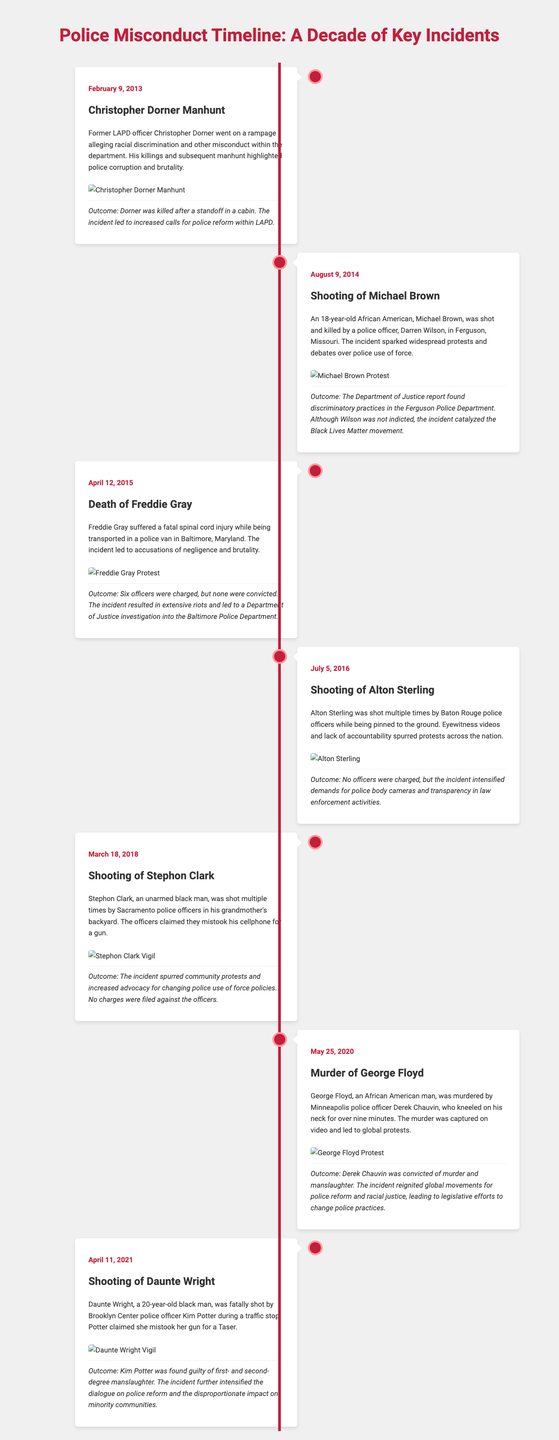What incident occurred on February 9, 2013? The incident that occurred on this date was the Christopher Dorner Manhunt, which involved allegations of racial discrimination and misconduct within the LAPD.
Answer: Christopher Dorner Manhunt Who was shot on August 9, 2014? On this date, Michael Brown, an 18-year-old African American, was shot and killed by a police officer in Ferguson, Missouri.
Answer: Michael Brown How many officers were charged in the Freddie Gray case? Six officers were charged in the incident involving Freddie Gray, but no convictions followed.
Answer: Six What sparked widespread protests after the shooting of Alton Sterling? Eyewitness videos and lack of accountability for the officers involved spurred protests across the nation.
Answer: Eyewitness videos What was the outcome of the George Floyd murder? Derek Chauvin was convicted of murder and manslaughter following the incident.
Answer: Convicted What led to increased calls for police reform within the LAPD? The Christopher Dorner Manhunt highlighted issues of police corruption and brutality, leading to calls for reform.
Answer: Calls for reform Which incident ignited the Black Lives Matter movement? The shooting and death of Michael Brown were key events that catalyzed the movement.
Answer: Michael Brown On which date did the shooting of Daunte Wright occur? The shooting of Daunte Wright occurred on April 11, 2021.
Answer: April 11, 2021 